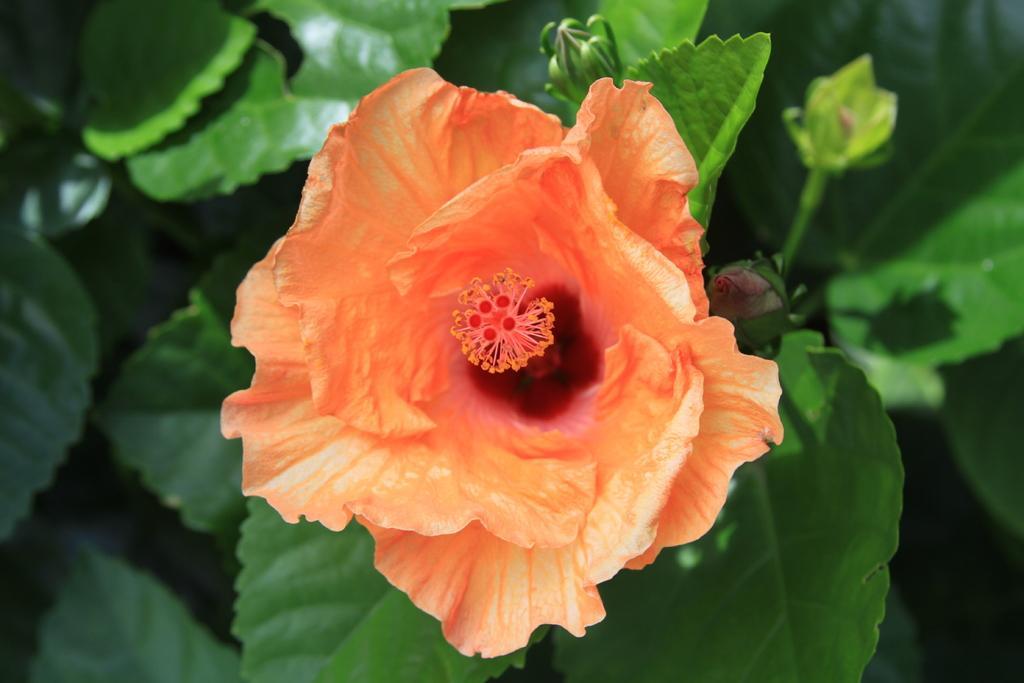Describe this image in one or two sentences. In the picture I can see a flower which is in orange color and there are few green leaves below it. 